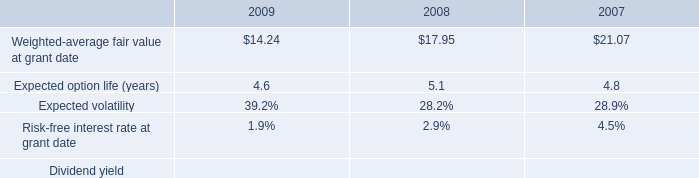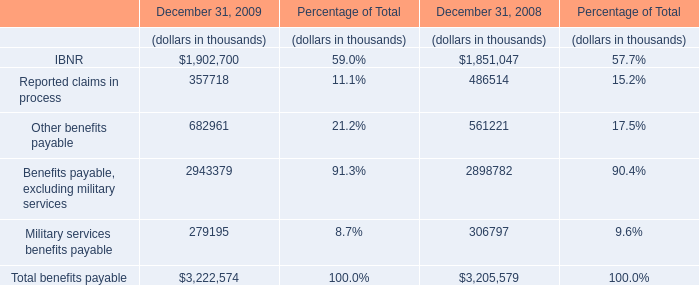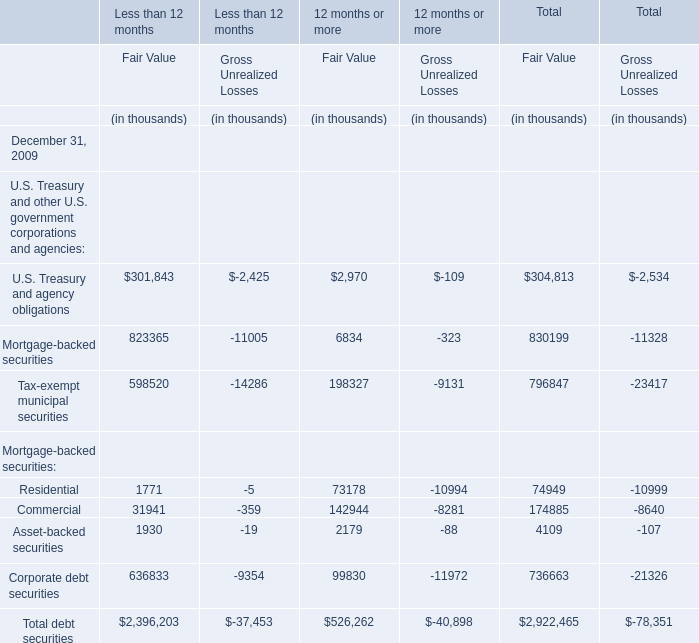Which element for Fair Value of Less than 12 months exceeds 20 % of total in 2009? 
Answer: Mortgage-backed securities, Tax-exempt municipal securities,Corporate debt securities. 